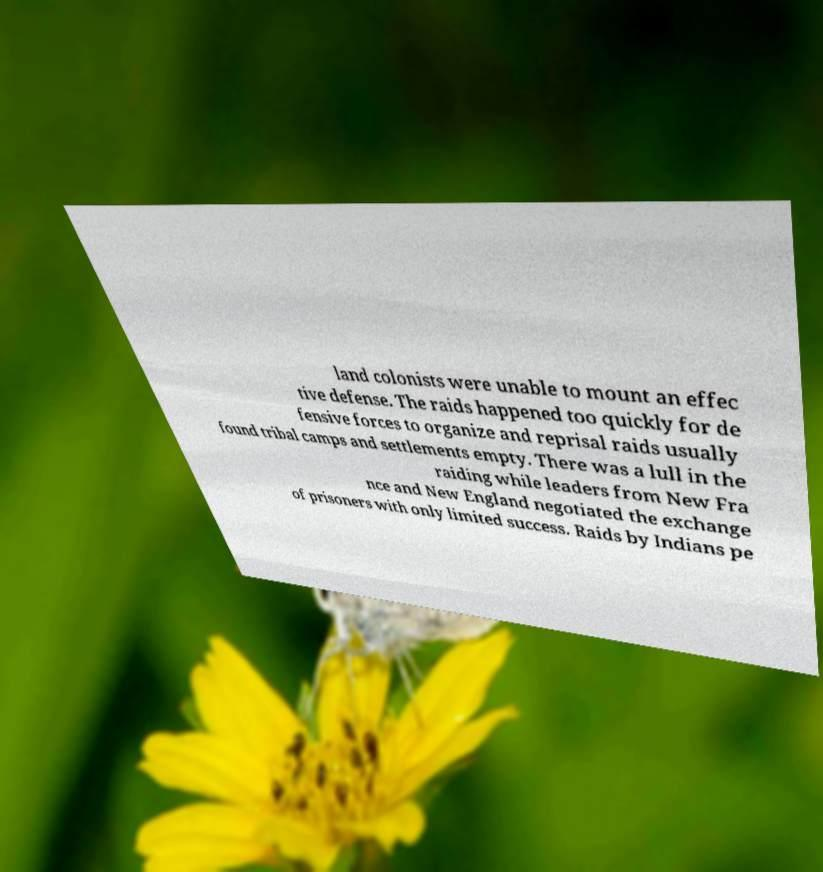Please identify and transcribe the text found in this image. land colonists were unable to mount an effec tive defense. The raids happened too quickly for de fensive forces to organize and reprisal raids usually found tribal camps and settlements empty. There was a lull in the raiding while leaders from New Fra nce and New England negotiated the exchange of prisoners with only limited success. Raids by Indians pe 